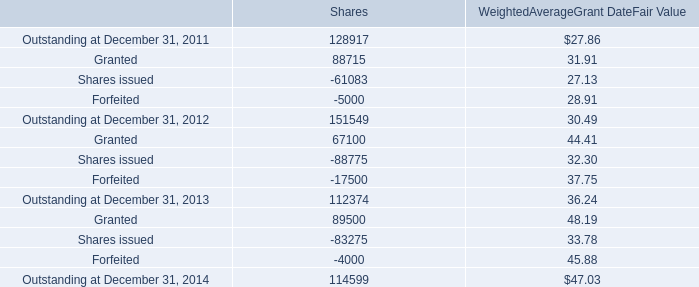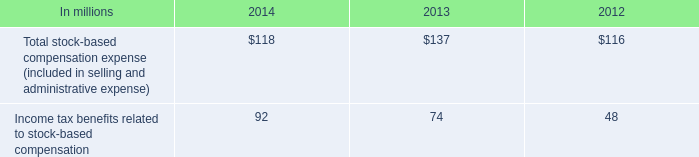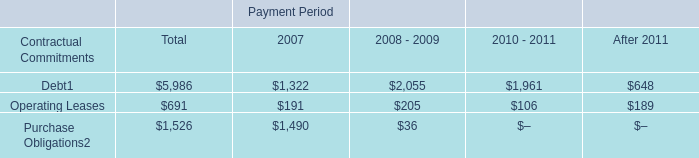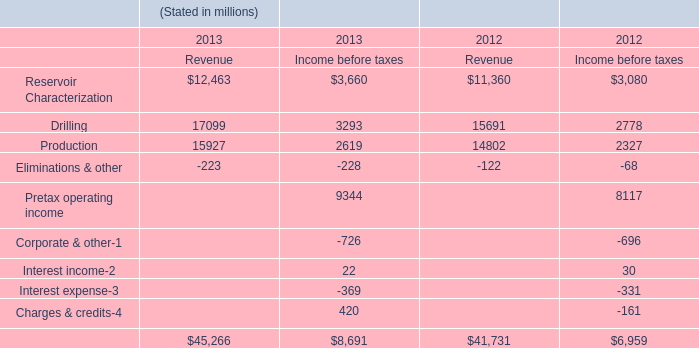How much of Revenue is there in total in 2013 without Production and Eliminations & other? (in million) 
Computations: (12463 + 17099)
Answer: 29562.0. 